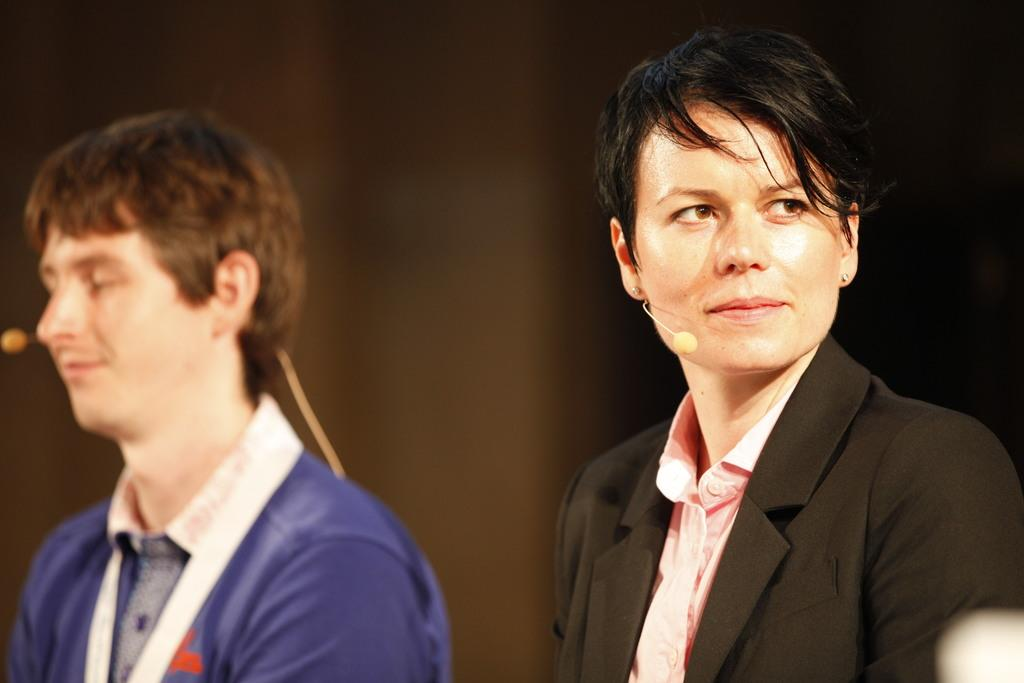How many people are in the image? There are two persons in the image. Can you describe the background of the image? The background of the image is blurry. How many jellyfish are swimming in the background of the image? There are no jellyfish present in the image, as the background is blurry and does not show any aquatic life. 